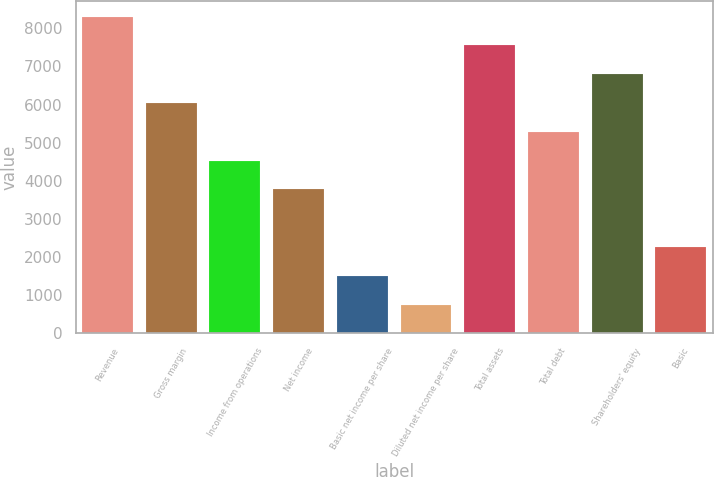Convert chart to OTSL. <chart><loc_0><loc_0><loc_500><loc_500><bar_chart><fcel>Revenue<fcel>Gross margin<fcel>Income from operations<fcel>Net income<fcel>Basic net income per share<fcel>Diluted net income per share<fcel>Total assets<fcel>Total debt<fcel>Shareholders' equity<fcel>Basic<nl><fcel>8308.23<fcel>6042.42<fcel>4531.88<fcel>3776.61<fcel>1510.8<fcel>755.53<fcel>7552.96<fcel>5287.15<fcel>6797.69<fcel>2266.07<nl></chart> 